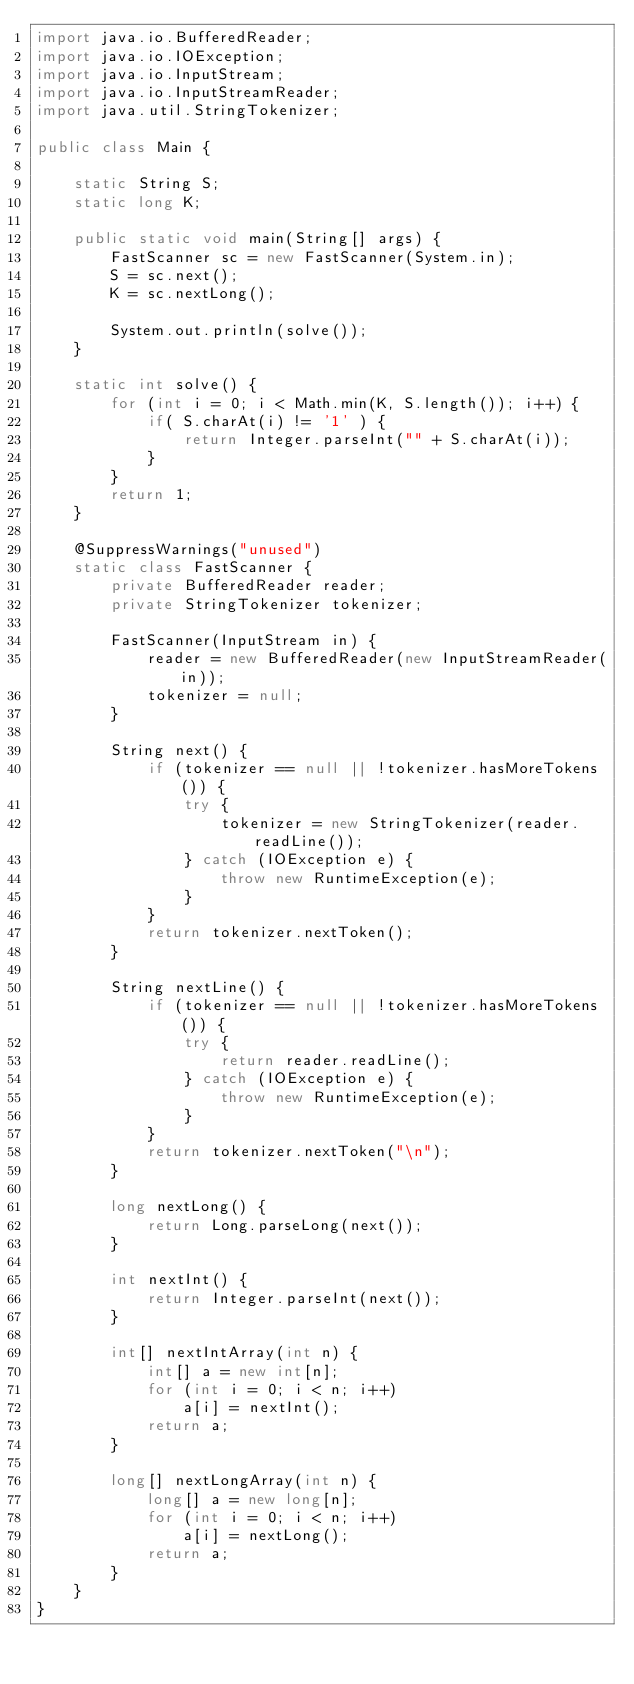<code> <loc_0><loc_0><loc_500><loc_500><_Java_>import java.io.BufferedReader;
import java.io.IOException;
import java.io.InputStream;
import java.io.InputStreamReader;
import java.util.StringTokenizer;

public class Main {

    static String S;
    static long K;

    public static void main(String[] args) {
        FastScanner sc = new FastScanner(System.in);
        S = sc.next();
        K = sc.nextLong();

        System.out.println(solve());
    }

    static int solve() {
        for (int i = 0; i < Math.min(K, S.length()); i++) {
            if( S.charAt(i) != '1' ) {
                return Integer.parseInt("" + S.charAt(i));
            }
        }
        return 1;
    }

    @SuppressWarnings("unused")
    static class FastScanner {
        private BufferedReader reader;
        private StringTokenizer tokenizer;

        FastScanner(InputStream in) {
            reader = new BufferedReader(new InputStreamReader(in));
            tokenizer = null;
        }

        String next() {
            if (tokenizer == null || !tokenizer.hasMoreTokens()) {
                try {
                    tokenizer = new StringTokenizer(reader.readLine());
                } catch (IOException e) {
                    throw new RuntimeException(e);
                }
            }
            return tokenizer.nextToken();
        }

        String nextLine() {
            if (tokenizer == null || !tokenizer.hasMoreTokens()) {
                try {
                    return reader.readLine();
                } catch (IOException e) {
                    throw new RuntimeException(e);
                }
            }
            return tokenizer.nextToken("\n");
        }

        long nextLong() {
            return Long.parseLong(next());
        }

        int nextInt() {
            return Integer.parseInt(next());
        }

        int[] nextIntArray(int n) {
            int[] a = new int[n];
            for (int i = 0; i < n; i++)
                a[i] = nextInt();
            return a;
        }

        long[] nextLongArray(int n) {
            long[] a = new long[n];
            for (int i = 0; i < n; i++)
                a[i] = nextLong();
            return a;
        }
    }
}
</code> 